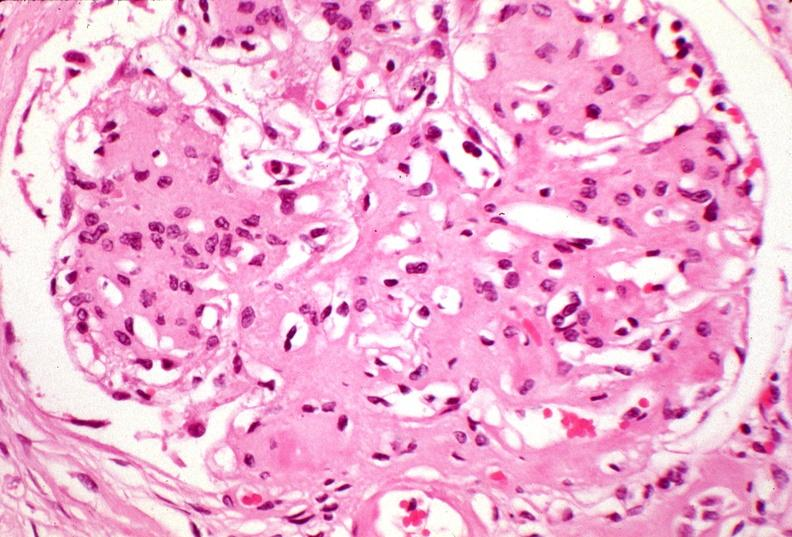where is this?
Answer the question using a single word or phrase. Urinary 